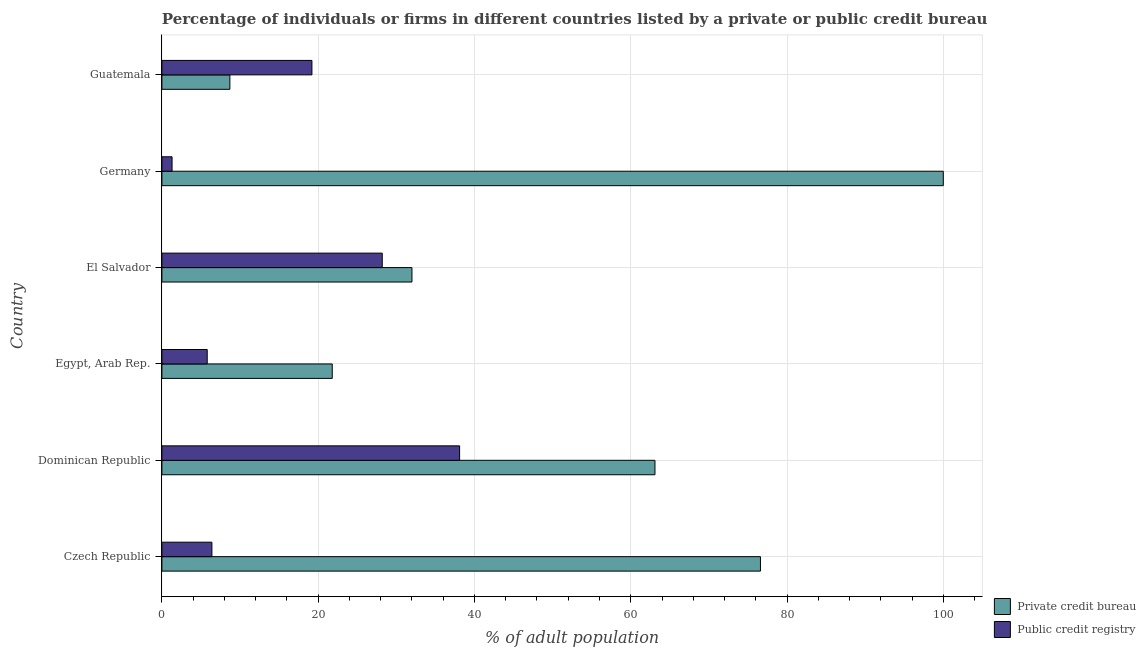How many groups of bars are there?
Provide a short and direct response. 6. Are the number of bars per tick equal to the number of legend labels?
Provide a short and direct response. Yes. How many bars are there on the 5th tick from the top?
Keep it short and to the point. 2. What is the label of the 3rd group of bars from the top?
Make the answer very short. El Salvador. In how many cases, is the number of bars for a given country not equal to the number of legend labels?
Give a very brief answer. 0. Across all countries, what is the minimum percentage of firms listed by public credit bureau?
Your answer should be very brief. 1.3. In which country was the percentage of firms listed by private credit bureau minimum?
Provide a short and direct response. Guatemala. What is the total percentage of firms listed by private credit bureau in the graph?
Keep it short and to the point. 302.2. What is the difference between the percentage of firms listed by private credit bureau in Czech Republic and that in Dominican Republic?
Provide a short and direct response. 13.5. What is the difference between the percentage of firms listed by private credit bureau in Czech Republic and the percentage of firms listed by public credit bureau in Germany?
Your answer should be very brief. 75.3. What is the average percentage of firms listed by private credit bureau per country?
Offer a terse response. 50.37. What is the difference between the percentage of firms listed by private credit bureau and percentage of firms listed by public credit bureau in El Salvador?
Offer a terse response. 3.8. What is the ratio of the percentage of firms listed by private credit bureau in Czech Republic to that in Germany?
Your response must be concise. 0.77. Is the percentage of firms listed by public credit bureau in Dominican Republic less than that in Guatemala?
Keep it short and to the point. No. Is the difference between the percentage of firms listed by private credit bureau in Czech Republic and Egypt, Arab Rep. greater than the difference between the percentage of firms listed by public credit bureau in Czech Republic and Egypt, Arab Rep.?
Provide a succinct answer. Yes. What is the difference between the highest and the second highest percentage of firms listed by private credit bureau?
Keep it short and to the point. 23.4. What is the difference between the highest and the lowest percentage of firms listed by public credit bureau?
Offer a terse response. 36.8. In how many countries, is the percentage of firms listed by private credit bureau greater than the average percentage of firms listed by private credit bureau taken over all countries?
Give a very brief answer. 3. What does the 2nd bar from the top in Guatemala represents?
Offer a terse response. Private credit bureau. What does the 2nd bar from the bottom in Czech Republic represents?
Offer a very short reply. Public credit registry. Are all the bars in the graph horizontal?
Keep it short and to the point. Yes. How many countries are there in the graph?
Your answer should be compact. 6. What is the difference between two consecutive major ticks on the X-axis?
Your answer should be very brief. 20. Where does the legend appear in the graph?
Your answer should be compact. Bottom right. How are the legend labels stacked?
Offer a very short reply. Vertical. What is the title of the graph?
Your answer should be compact. Percentage of individuals or firms in different countries listed by a private or public credit bureau. Does "Mobile cellular" appear as one of the legend labels in the graph?
Make the answer very short. No. What is the label or title of the X-axis?
Keep it short and to the point. % of adult population. What is the label or title of the Y-axis?
Give a very brief answer. Country. What is the % of adult population in Private credit bureau in Czech Republic?
Offer a terse response. 76.6. What is the % of adult population in Public credit registry in Czech Republic?
Offer a terse response. 6.4. What is the % of adult population in Private credit bureau in Dominican Republic?
Give a very brief answer. 63.1. What is the % of adult population of Public credit registry in Dominican Republic?
Provide a short and direct response. 38.1. What is the % of adult population of Private credit bureau in Egypt, Arab Rep.?
Ensure brevity in your answer.  21.8. What is the % of adult population in Private credit bureau in El Salvador?
Ensure brevity in your answer.  32. What is the % of adult population of Public credit registry in El Salvador?
Offer a very short reply. 28.2. What is the % of adult population in Public credit registry in Germany?
Keep it short and to the point. 1.3. What is the % of adult population of Public credit registry in Guatemala?
Ensure brevity in your answer.  19.2. Across all countries, what is the maximum % of adult population of Public credit registry?
Give a very brief answer. 38.1. What is the total % of adult population of Private credit bureau in the graph?
Your answer should be compact. 302.2. What is the difference between the % of adult population of Public credit registry in Czech Republic and that in Dominican Republic?
Make the answer very short. -31.7. What is the difference between the % of adult population of Private credit bureau in Czech Republic and that in Egypt, Arab Rep.?
Keep it short and to the point. 54.8. What is the difference between the % of adult population of Public credit registry in Czech Republic and that in Egypt, Arab Rep.?
Your response must be concise. 0.6. What is the difference between the % of adult population in Private credit bureau in Czech Republic and that in El Salvador?
Your answer should be compact. 44.6. What is the difference between the % of adult population in Public credit registry in Czech Republic and that in El Salvador?
Your response must be concise. -21.8. What is the difference between the % of adult population in Private credit bureau in Czech Republic and that in Germany?
Ensure brevity in your answer.  -23.4. What is the difference between the % of adult population in Private credit bureau in Czech Republic and that in Guatemala?
Keep it short and to the point. 67.9. What is the difference between the % of adult population of Public credit registry in Czech Republic and that in Guatemala?
Your response must be concise. -12.8. What is the difference between the % of adult population of Private credit bureau in Dominican Republic and that in Egypt, Arab Rep.?
Your response must be concise. 41.3. What is the difference between the % of adult population in Public credit registry in Dominican Republic and that in Egypt, Arab Rep.?
Your response must be concise. 32.3. What is the difference between the % of adult population in Private credit bureau in Dominican Republic and that in El Salvador?
Offer a very short reply. 31.1. What is the difference between the % of adult population of Public credit registry in Dominican Republic and that in El Salvador?
Your answer should be very brief. 9.9. What is the difference between the % of adult population of Private credit bureau in Dominican Republic and that in Germany?
Provide a succinct answer. -36.9. What is the difference between the % of adult population of Public credit registry in Dominican Republic and that in Germany?
Provide a succinct answer. 36.8. What is the difference between the % of adult population of Private credit bureau in Dominican Republic and that in Guatemala?
Make the answer very short. 54.4. What is the difference between the % of adult population of Public credit registry in Egypt, Arab Rep. and that in El Salvador?
Offer a terse response. -22.4. What is the difference between the % of adult population of Private credit bureau in Egypt, Arab Rep. and that in Germany?
Ensure brevity in your answer.  -78.2. What is the difference between the % of adult population in Private credit bureau in Egypt, Arab Rep. and that in Guatemala?
Make the answer very short. 13.1. What is the difference between the % of adult population in Public credit registry in Egypt, Arab Rep. and that in Guatemala?
Offer a very short reply. -13.4. What is the difference between the % of adult population in Private credit bureau in El Salvador and that in Germany?
Offer a terse response. -68. What is the difference between the % of adult population of Public credit registry in El Salvador and that in Germany?
Offer a terse response. 26.9. What is the difference between the % of adult population in Private credit bureau in El Salvador and that in Guatemala?
Ensure brevity in your answer.  23.3. What is the difference between the % of adult population of Private credit bureau in Germany and that in Guatemala?
Provide a succinct answer. 91.3. What is the difference between the % of adult population of Public credit registry in Germany and that in Guatemala?
Your answer should be compact. -17.9. What is the difference between the % of adult population of Private credit bureau in Czech Republic and the % of adult population of Public credit registry in Dominican Republic?
Provide a succinct answer. 38.5. What is the difference between the % of adult population in Private credit bureau in Czech Republic and the % of adult population in Public credit registry in Egypt, Arab Rep.?
Offer a terse response. 70.8. What is the difference between the % of adult population in Private credit bureau in Czech Republic and the % of adult population in Public credit registry in El Salvador?
Provide a succinct answer. 48.4. What is the difference between the % of adult population of Private credit bureau in Czech Republic and the % of adult population of Public credit registry in Germany?
Offer a terse response. 75.3. What is the difference between the % of adult population of Private credit bureau in Czech Republic and the % of adult population of Public credit registry in Guatemala?
Provide a succinct answer. 57.4. What is the difference between the % of adult population in Private credit bureau in Dominican Republic and the % of adult population in Public credit registry in Egypt, Arab Rep.?
Make the answer very short. 57.3. What is the difference between the % of adult population in Private credit bureau in Dominican Republic and the % of adult population in Public credit registry in El Salvador?
Your answer should be very brief. 34.9. What is the difference between the % of adult population in Private credit bureau in Dominican Republic and the % of adult population in Public credit registry in Germany?
Provide a short and direct response. 61.8. What is the difference between the % of adult population of Private credit bureau in Dominican Republic and the % of adult population of Public credit registry in Guatemala?
Your answer should be compact. 43.9. What is the difference between the % of adult population of Private credit bureau in Egypt, Arab Rep. and the % of adult population of Public credit registry in Germany?
Your response must be concise. 20.5. What is the difference between the % of adult population in Private credit bureau in Egypt, Arab Rep. and the % of adult population in Public credit registry in Guatemala?
Provide a short and direct response. 2.6. What is the difference between the % of adult population of Private credit bureau in El Salvador and the % of adult population of Public credit registry in Germany?
Provide a short and direct response. 30.7. What is the difference between the % of adult population in Private credit bureau in Germany and the % of adult population in Public credit registry in Guatemala?
Your answer should be very brief. 80.8. What is the average % of adult population of Private credit bureau per country?
Your response must be concise. 50.37. What is the difference between the % of adult population of Private credit bureau and % of adult population of Public credit registry in Czech Republic?
Offer a terse response. 70.2. What is the difference between the % of adult population in Private credit bureau and % of adult population in Public credit registry in El Salvador?
Keep it short and to the point. 3.8. What is the difference between the % of adult population in Private credit bureau and % of adult population in Public credit registry in Germany?
Your response must be concise. 98.7. What is the difference between the % of adult population of Private credit bureau and % of adult population of Public credit registry in Guatemala?
Provide a succinct answer. -10.5. What is the ratio of the % of adult population in Private credit bureau in Czech Republic to that in Dominican Republic?
Your answer should be very brief. 1.21. What is the ratio of the % of adult population in Public credit registry in Czech Republic to that in Dominican Republic?
Make the answer very short. 0.17. What is the ratio of the % of adult population of Private credit bureau in Czech Republic to that in Egypt, Arab Rep.?
Offer a very short reply. 3.51. What is the ratio of the % of adult population of Public credit registry in Czech Republic to that in Egypt, Arab Rep.?
Give a very brief answer. 1.1. What is the ratio of the % of adult population in Private credit bureau in Czech Republic to that in El Salvador?
Offer a terse response. 2.39. What is the ratio of the % of adult population of Public credit registry in Czech Republic to that in El Salvador?
Provide a succinct answer. 0.23. What is the ratio of the % of adult population in Private credit bureau in Czech Republic to that in Germany?
Ensure brevity in your answer.  0.77. What is the ratio of the % of adult population in Public credit registry in Czech Republic to that in Germany?
Offer a very short reply. 4.92. What is the ratio of the % of adult population of Private credit bureau in Czech Republic to that in Guatemala?
Ensure brevity in your answer.  8.8. What is the ratio of the % of adult population in Private credit bureau in Dominican Republic to that in Egypt, Arab Rep.?
Your answer should be very brief. 2.89. What is the ratio of the % of adult population of Public credit registry in Dominican Republic to that in Egypt, Arab Rep.?
Provide a succinct answer. 6.57. What is the ratio of the % of adult population of Private credit bureau in Dominican Republic to that in El Salvador?
Offer a terse response. 1.97. What is the ratio of the % of adult population in Public credit registry in Dominican Republic to that in El Salvador?
Provide a succinct answer. 1.35. What is the ratio of the % of adult population in Private credit bureau in Dominican Republic to that in Germany?
Your answer should be very brief. 0.63. What is the ratio of the % of adult population of Public credit registry in Dominican Republic to that in Germany?
Offer a terse response. 29.31. What is the ratio of the % of adult population of Private credit bureau in Dominican Republic to that in Guatemala?
Your answer should be very brief. 7.25. What is the ratio of the % of adult population in Public credit registry in Dominican Republic to that in Guatemala?
Offer a very short reply. 1.98. What is the ratio of the % of adult population in Private credit bureau in Egypt, Arab Rep. to that in El Salvador?
Your response must be concise. 0.68. What is the ratio of the % of adult population in Public credit registry in Egypt, Arab Rep. to that in El Salvador?
Provide a succinct answer. 0.21. What is the ratio of the % of adult population in Private credit bureau in Egypt, Arab Rep. to that in Germany?
Make the answer very short. 0.22. What is the ratio of the % of adult population in Public credit registry in Egypt, Arab Rep. to that in Germany?
Keep it short and to the point. 4.46. What is the ratio of the % of adult population in Private credit bureau in Egypt, Arab Rep. to that in Guatemala?
Provide a short and direct response. 2.51. What is the ratio of the % of adult population in Public credit registry in Egypt, Arab Rep. to that in Guatemala?
Offer a very short reply. 0.3. What is the ratio of the % of adult population of Private credit bureau in El Salvador to that in Germany?
Offer a terse response. 0.32. What is the ratio of the % of adult population of Public credit registry in El Salvador to that in Germany?
Give a very brief answer. 21.69. What is the ratio of the % of adult population of Private credit bureau in El Salvador to that in Guatemala?
Your response must be concise. 3.68. What is the ratio of the % of adult population of Public credit registry in El Salvador to that in Guatemala?
Offer a very short reply. 1.47. What is the ratio of the % of adult population in Private credit bureau in Germany to that in Guatemala?
Your answer should be very brief. 11.49. What is the ratio of the % of adult population of Public credit registry in Germany to that in Guatemala?
Give a very brief answer. 0.07. What is the difference between the highest and the second highest % of adult population of Private credit bureau?
Provide a succinct answer. 23.4. What is the difference between the highest and the lowest % of adult population in Private credit bureau?
Give a very brief answer. 91.3. What is the difference between the highest and the lowest % of adult population of Public credit registry?
Your answer should be compact. 36.8. 